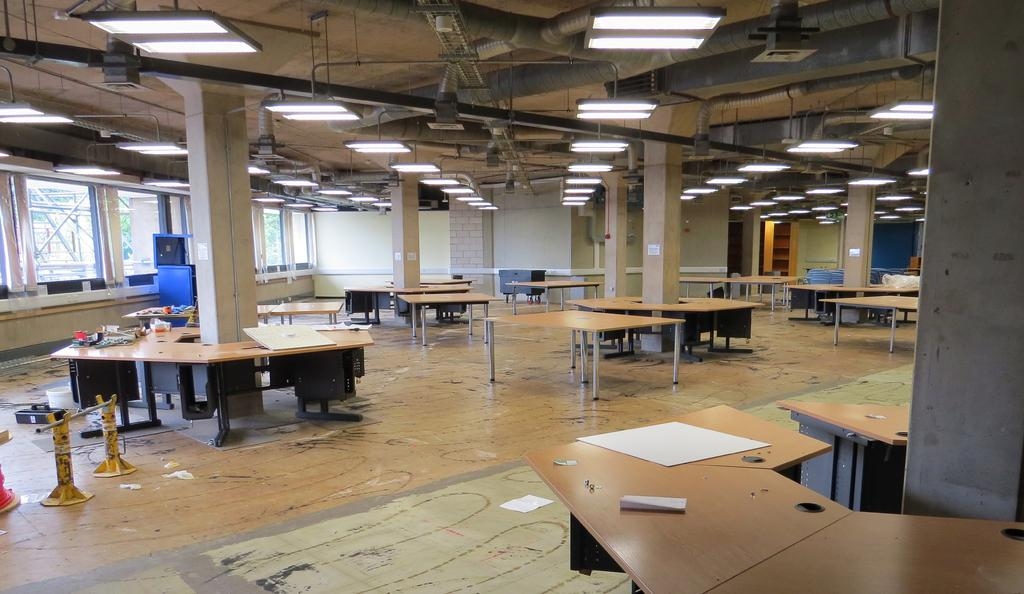What type of furniture is present in the image? There are tables in the image. What color are the tables? The tables are cream-colored. What architectural elements can be seen in the image? There are pillars and walls in the image. What color are the pillars and walls? The pillars are white-colored, and the walls are also white-colored. What other features are present in the image? There are windows and lights in the image. How many bones can be seen on the floor in the image? There are no bones present in the image. What are the boys doing in the image? There are no boys present in the image. 